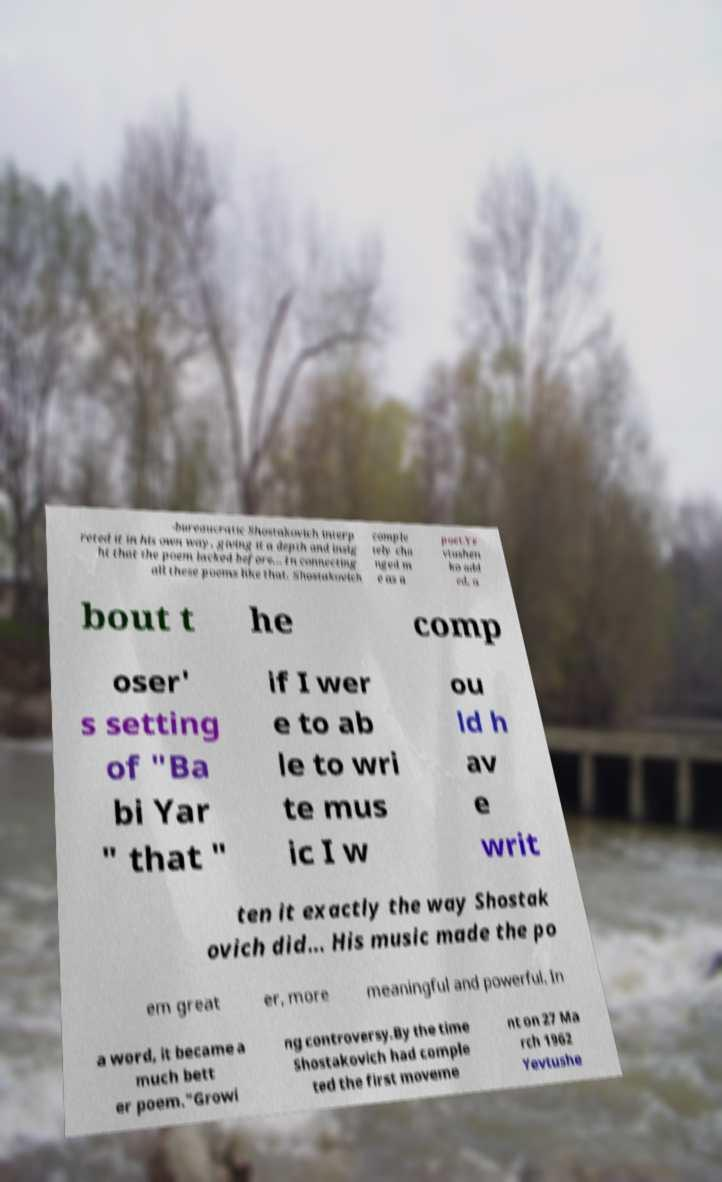Please read and relay the text visible in this image. What does it say? -bureaucratic Shostakovich interp reted it in his own way, giving it a depth and insig ht that the poem lacked before... In connecting all these poems like that, Shostakovich comple tely cha nged m e as a poet.Ye vtushen ko add ed, a bout t he comp oser' s setting of "Ba bi Yar " that " if I wer e to ab le to wri te mus ic I w ou ld h av e writ ten it exactly the way Shostak ovich did... His music made the po em great er, more meaningful and powerful. In a word, it became a much bett er poem."Growi ng controversy.By the time Shostakovich had comple ted the first moveme nt on 27 Ma rch 1962 Yevtushe 